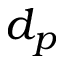<formula> <loc_0><loc_0><loc_500><loc_500>d _ { p }</formula> 